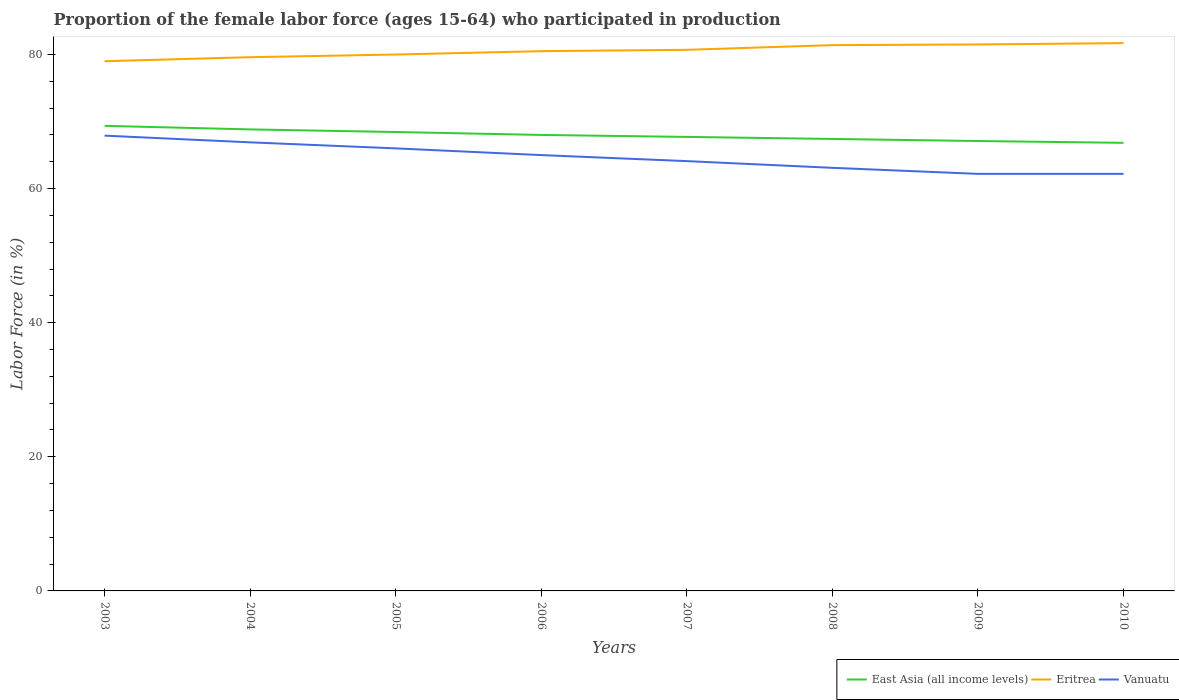Across all years, what is the maximum proportion of the female labor force who participated in production in East Asia (all income levels)?
Provide a short and direct response. 66.83. What is the total proportion of the female labor force who participated in production in East Asia (all income levels) in the graph?
Provide a succinct answer. 2.53. What is the difference between the highest and the second highest proportion of the female labor force who participated in production in Vanuatu?
Provide a succinct answer. 5.7. What is the difference between the highest and the lowest proportion of the female labor force who participated in production in Vanuatu?
Offer a very short reply. 4. How many lines are there?
Your answer should be compact. 3. What is the difference between two consecutive major ticks on the Y-axis?
Offer a very short reply. 20. Are the values on the major ticks of Y-axis written in scientific E-notation?
Keep it short and to the point. No. Does the graph contain any zero values?
Provide a short and direct response. No. Where does the legend appear in the graph?
Make the answer very short. Bottom right. How many legend labels are there?
Ensure brevity in your answer.  3. What is the title of the graph?
Ensure brevity in your answer.  Proportion of the female labor force (ages 15-64) who participated in production. What is the label or title of the X-axis?
Give a very brief answer. Years. What is the label or title of the Y-axis?
Provide a short and direct response. Labor Force (in %). What is the Labor Force (in %) of East Asia (all income levels) in 2003?
Provide a succinct answer. 69.36. What is the Labor Force (in %) in Eritrea in 2003?
Ensure brevity in your answer.  79. What is the Labor Force (in %) in Vanuatu in 2003?
Make the answer very short. 67.9. What is the Labor Force (in %) in East Asia (all income levels) in 2004?
Offer a terse response. 68.83. What is the Labor Force (in %) of Eritrea in 2004?
Give a very brief answer. 79.6. What is the Labor Force (in %) in Vanuatu in 2004?
Your response must be concise. 66.9. What is the Labor Force (in %) of East Asia (all income levels) in 2005?
Provide a succinct answer. 68.44. What is the Labor Force (in %) of Eritrea in 2005?
Your response must be concise. 80. What is the Labor Force (in %) in East Asia (all income levels) in 2006?
Offer a very short reply. 68.01. What is the Labor Force (in %) in Eritrea in 2006?
Your answer should be very brief. 80.5. What is the Labor Force (in %) in East Asia (all income levels) in 2007?
Ensure brevity in your answer.  67.71. What is the Labor Force (in %) in Eritrea in 2007?
Your answer should be very brief. 80.7. What is the Labor Force (in %) in Vanuatu in 2007?
Ensure brevity in your answer.  64.1. What is the Labor Force (in %) of East Asia (all income levels) in 2008?
Your answer should be compact. 67.41. What is the Labor Force (in %) of Eritrea in 2008?
Offer a terse response. 81.4. What is the Labor Force (in %) in Vanuatu in 2008?
Offer a terse response. 63.1. What is the Labor Force (in %) in East Asia (all income levels) in 2009?
Keep it short and to the point. 67.1. What is the Labor Force (in %) in Eritrea in 2009?
Make the answer very short. 81.5. What is the Labor Force (in %) in Vanuatu in 2009?
Your answer should be compact. 62.2. What is the Labor Force (in %) in East Asia (all income levels) in 2010?
Keep it short and to the point. 66.83. What is the Labor Force (in %) of Eritrea in 2010?
Give a very brief answer. 81.7. What is the Labor Force (in %) of Vanuatu in 2010?
Your answer should be very brief. 62.2. Across all years, what is the maximum Labor Force (in %) of East Asia (all income levels)?
Provide a short and direct response. 69.36. Across all years, what is the maximum Labor Force (in %) of Eritrea?
Your answer should be very brief. 81.7. Across all years, what is the maximum Labor Force (in %) of Vanuatu?
Your response must be concise. 67.9. Across all years, what is the minimum Labor Force (in %) in East Asia (all income levels)?
Keep it short and to the point. 66.83. Across all years, what is the minimum Labor Force (in %) of Eritrea?
Provide a short and direct response. 79. Across all years, what is the minimum Labor Force (in %) in Vanuatu?
Provide a short and direct response. 62.2. What is the total Labor Force (in %) of East Asia (all income levels) in the graph?
Make the answer very short. 543.69. What is the total Labor Force (in %) of Eritrea in the graph?
Give a very brief answer. 644.4. What is the total Labor Force (in %) of Vanuatu in the graph?
Keep it short and to the point. 517.4. What is the difference between the Labor Force (in %) of East Asia (all income levels) in 2003 and that in 2004?
Your answer should be compact. 0.53. What is the difference between the Labor Force (in %) of East Asia (all income levels) in 2003 and that in 2005?
Ensure brevity in your answer.  0.92. What is the difference between the Labor Force (in %) of Vanuatu in 2003 and that in 2005?
Your response must be concise. 1.9. What is the difference between the Labor Force (in %) in East Asia (all income levels) in 2003 and that in 2006?
Provide a short and direct response. 1.36. What is the difference between the Labor Force (in %) of Vanuatu in 2003 and that in 2006?
Provide a short and direct response. 2.9. What is the difference between the Labor Force (in %) of East Asia (all income levels) in 2003 and that in 2007?
Offer a terse response. 1.65. What is the difference between the Labor Force (in %) of Vanuatu in 2003 and that in 2007?
Your answer should be very brief. 3.8. What is the difference between the Labor Force (in %) of East Asia (all income levels) in 2003 and that in 2008?
Your response must be concise. 1.95. What is the difference between the Labor Force (in %) of Eritrea in 2003 and that in 2008?
Provide a short and direct response. -2.4. What is the difference between the Labor Force (in %) in Vanuatu in 2003 and that in 2008?
Your response must be concise. 4.8. What is the difference between the Labor Force (in %) in East Asia (all income levels) in 2003 and that in 2009?
Your response must be concise. 2.26. What is the difference between the Labor Force (in %) of Eritrea in 2003 and that in 2009?
Keep it short and to the point. -2.5. What is the difference between the Labor Force (in %) of Vanuatu in 2003 and that in 2009?
Your answer should be very brief. 5.7. What is the difference between the Labor Force (in %) in East Asia (all income levels) in 2003 and that in 2010?
Keep it short and to the point. 2.53. What is the difference between the Labor Force (in %) in Vanuatu in 2003 and that in 2010?
Ensure brevity in your answer.  5.7. What is the difference between the Labor Force (in %) of East Asia (all income levels) in 2004 and that in 2005?
Give a very brief answer. 0.39. What is the difference between the Labor Force (in %) of East Asia (all income levels) in 2004 and that in 2006?
Offer a terse response. 0.82. What is the difference between the Labor Force (in %) of East Asia (all income levels) in 2004 and that in 2007?
Your answer should be very brief. 1.12. What is the difference between the Labor Force (in %) of Vanuatu in 2004 and that in 2007?
Provide a succinct answer. 2.8. What is the difference between the Labor Force (in %) in East Asia (all income levels) in 2004 and that in 2008?
Keep it short and to the point. 1.42. What is the difference between the Labor Force (in %) of East Asia (all income levels) in 2004 and that in 2009?
Give a very brief answer. 1.73. What is the difference between the Labor Force (in %) in Eritrea in 2004 and that in 2009?
Ensure brevity in your answer.  -1.9. What is the difference between the Labor Force (in %) of East Asia (all income levels) in 2004 and that in 2010?
Provide a short and direct response. 2. What is the difference between the Labor Force (in %) of Eritrea in 2004 and that in 2010?
Offer a very short reply. -2.1. What is the difference between the Labor Force (in %) in Vanuatu in 2004 and that in 2010?
Offer a terse response. 4.7. What is the difference between the Labor Force (in %) in East Asia (all income levels) in 2005 and that in 2006?
Provide a short and direct response. 0.43. What is the difference between the Labor Force (in %) of Vanuatu in 2005 and that in 2006?
Give a very brief answer. 1. What is the difference between the Labor Force (in %) in East Asia (all income levels) in 2005 and that in 2007?
Provide a succinct answer. 0.73. What is the difference between the Labor Force (in %) in Vanuatu in 2005 and that in 2007?
Your response must be concise. 1.9. What is the difference between the Labor Force (in %) in East Asia (all income levels) in 2005 and that in 2008?
Keep it short and to the point. 1.03. What is the difference between the Labor Force (in %) of East Asia (all income levels) in 2005 and that in 2009?
Offer a terse response. 1.34. What is the difference between the Labor Force (in %) of Eritrea in 2005 and that in 2009?
Give a very brief answer. -1.5. What is the difference between the Labor Force (in %) in East Asia (all income levels) in 2005 and that in 2010?
Your response must be concise. 1.61. What is the difference between the Labor Force (in %) of East Asia (all income levels) in 2006 and that in 2007?
Your answer should be compact. 0.29. What is the difference between the Labor Force (in %) in East Asia (all income levels) in 2006 and that in 2008?
Your answer should be very brief. 0.6. What is the difference between the Labor Force (in %) of East Asia (all income levels) in 2006 and that in 2009?
Make the answer very short. 0.91. What is the difference between the Labor Force (in %) in East Asia (all income levels) in 2006 and that in 2010?
Offer a terse response. 1.18. What is the difference between the Labor Force (in %) of Eritrea in 2006 and that in 2010?
Offer a very short reply. -1.2. What is the difference between the Labor Force (in %) of East Asia (all income levels) in 2007 and that in 2008?
Make the answer very short. 0.3. What is the difference between the Labor Force (in %) in Eritrea in 2007 and that in 2008?
Provide a short and direct response. -0.7. What is the difference between the Labor Force (in %) of East Asia (all income levels) in 2007 and that in 2009?
Provide a succinct answer. 0.61. What is the difference between the Labor Force (in %) in Eritrea in 2007 and that in 2009?
Provide a succinct answer. -0.8. What is the difference between the Labor Force (in %) of East Asia (all income levels) in 2007 and that in 2010?
Offer a terse response. 0.88. What is the difference between the Labor Force (in %) of East Asia (all income levels) in 2008 and that in 2009?
Offer a terse response. 0.31. What is the difference between the Labor Force (in %) of Vanuatu in 2008 and that in 2009?
Offer a very short reply. 0.9. What is the difference between the Labor Force (in %) in East Asia (all income levels) in 2008 and that in 2010?
Provide a succinct answer. 0.58. What is the difference between the Labor Force (in %) in Eritrea in 2008 and that in 2010?
Ensure brevity in your answer.  -0.3. What is the difference between the Labor Force (in %) of East Asia (all income levels) in 2009 and that in 2010?
Make the answer very short. 0.27. What is the difference between the Labor Force (in %) of Eritrea in 2009 and that in 2010?
Give a very brief answer. -0.2. What is the difference between the Labor Force (in %) of Vanuatu in 2009 and that in 2010?
Offer a very short reply. 0. What is the difference between the Labor Force (in %) of East Asia (all income levels) in 2003 and the Labor Force (in %) of Eritrea in 2004?
Your response must be concise. -10.24. What is the difference between the Labor Force (in %) in East Asia (all income levels) in 2003 and the Labor Force (in %) in Vanuatu in 2004?
Make the answer very short. 2.46. What is the difference between the Labor Force (in %) in East Asia (all income levels) in 2003 and the Labor Force (in %) in Eritrea in 2005?
Ensure brevity in your answer.  -10.64. What is the difference between the Labor Force (in %) in East Asia (all income levels) in 2003 and the Labor Force (in %) in Vanuatu in 2005?
Your answer should be very brief. 3.36. What is the difference between the Labor Force (in %) of Eritrea in 2003 and the Labor Force (in %) of Vanuatu in 2005?
Make the answer very short. 13. What is the difference between the Labor Force (in %) of East Asia (all income levels) in 2003 and the Labor Force (in %) of Eritrea in 2006?
Make the answer very short. -11.14. What is the difference between the Labor Force (in %) in East Asia (all income levels) in 2003 and the Labor Force (in %) in Vanuatu in 2006?
Offer a terse response. 4.36. What is the difference between the Labor Force (in %) in Eritrea in 2003 and the Labor Force (in %) in Vanuatu in 2006?
Keep it short and to the point. 14. What is the difference between the Labor Force (in %) in East Asia (all income levels) in 2003 and the Labor Force (in %) in Eritrea in 2007?
Give a very brief answer. -11.34. What is the difference between the Labor Force (in %) in East Asia (all income levels) in 2003 and the Labor Force (in %) in Vanuatu in 2007?
Your answer should be very brief. 5.26. What is the difference between the Labor Force (in %) in Eritrea in 2003 and the Labor Force (in %) in Vanuatu in 2007?
Offer a terse response. 14.9. What is the difference between the Labor Force (in %) in East Asia (all income levels) in 2003 and the Labor Force (in %) in Eritrea in 2008?
Offer a terse response. -12.04. What is the difference between the Labor Force (in %) of East Asia (all income levels) in 2003 and the Labor Force (in %) of Vanuatu in 2008?
Your answer should be compact. 6.26. What is the difference between the Labor Force (in %) of East Asia (all income levels) in 2003 and the Labor Force (in %) of Eritrea in 2009?
Offer a very short reply. -12.14. What is the difference between the Labor Force (in %) in East Asia (all income levels) in 2003 and the Labor Force (in %) in Vanuatu in 2009?
Keep it short and to the point. 7.16. What is the difference between the Labor Force (in %) of Eritrea in 2003 and the Labor Force (in %) of Vanuatu in 2009?
Your answer should be compact. 16.8. What is the difference between the Labor Force (in %) of East Asia (all income levels) in 2003 and the Labor Force (in %) of Eritrea in 2010?
Provide a succinct answer. -12.34. What is the difference between the Labor Force (in %) in East Asia (all income levels) in 2003 and the Labor Force (in %) in Vanuatu in 2010?
Make the answer very short. 7.16. What is the difference between the Labor Force (in %) of Eritrea in 2003 and the Labor Force (in %) of Vanuatu in 2010?
Provide a succinct answer. 16.8. What is the difference between the Labor Force (in %) in East Asia (all income levels) in 2004 and the Labor Force (in %) in Eritrea in 2005?
Your answer should be compact. -11.17. What is the difference between the Labor Force (in %) in East Asia (all income levels) in 2004 and the Labor Force (in %) in Vanuatu in 2005?
Provide a short and direct response. 2.83. What is the difference between the Labor Force (in %) in East Asia (all income levels) in 2004 and the Labor Force (in %) in Eritrea in 2006?
Provide a succinct answer. -11.67. What is the difference between the Labor Force (in %) of East Asia (all income levels) in 2004 and the Labor Force (in %) of Vanuatu in 2006?
Provide a succinct answer. 3.83. What is the difference between the Labor Force (in %) of Eritrea in 2004 and the Labor Force (in %) of Vanuatu in 2006?
Offer a terse response. 14.6. What is the difference between the Labor Force (in %) in East Asia (all income levels) in 2004 and the Labor Force (in %) in Eritrea in 2007?
Your answer should be very brief. -11.87. What is the difference between the Labor Force (in %) in East Asia (all income levels) in 2004 and the Labor Force (in %) in Vanuatu in 2007?
Offer a very short reply. 4.73. What is the difference between the Labor Force (in %) in Eritrea in 2004 and the Labor Force (in %) in Vanuatu in 2007?
Provide a short and direct response. 15.5. What is the difference between the Labor Force (in %) of East Asia (all income levels) in 2004 and the Labor Force (in %) of Eritrea in 2008?
Offer a very short reply. -12.57. What is the difference between the Labor Force (in %) of East Asia (all income levels) in 2004 and the Labor Force (in %) of Vanuatu in 2008?
Ensure brevity in your answer.  5.73. What is the difference between the Labor Force (in %) of East Asia (all income levels) in 2004 and the Labor Force (in %) of Eritrea in 2009?
Your answer should be very brief. -12.67. What is the difference between the Labor Force (in %) in East Asia (all income levels) in 2004 and the Labor Force (in %) in Vanuatu in 2009?
Your answer should be very brief. 6.63. What is the difference between the Labor Force (in %) of East Asia (all income levels) in 2004 and the Labor Force (in %) of Eritrea in 2010?
Offer a very short reply. -12.87. What is the difference between the Labor Force (in %) in East Asia (all income levels) in 2004 and the Labor Force (in %) in Vanuatu in 2010?
Offer a very short reply. 6.63. What is the difference between the Labor Force (in %) in Eritrea in 2004 and the Labor Force (in %) in Vanuatu in 2010?
Provide a succinct answer. 17.4. What is the difference between the Labor Force (in %) in East Asia (all income levels) in 2005 and the Labor Force (in %) in Eritrea in 2006?
Offer a very short reply. -12.06. What is the difference between the Labor Force (in %) in East Asia (all income levels) in 2005 and the Labor Force (in %) in Vanuatu in 2006?
Provide a succinct answer. 3.44. What is the difference between the Labor Force (in %) in Eritrea in 2005 and the Labor Force (in %) in Vanuatu in 2006?
Provide a short and direct response. 15. What is the difference between the Labor Force (in %) in East Asia (all income levels) in 2005 and the Labor Force (in %) in Eritrea in 2007?
Keep it short and to the point. -12.26. What is the difference between the Labor Force (in %) in East Asia (all income levels) in 2005 and the Labor Force (in %) in Vanuatu in 2007?
Offer a terse response. 4.34. What is the difference between the Labor Force (in %) in Eritrea in 2005 and the Labor Force (in %) in Vanuatu in 2007?
Your answer should be very brief. 15.9. What is the difference between the Labor Force (in %) in East Asia (all income levels) in 2005 and the Labor Force (in %) in Eritrea in 2008?
Provide a succinct answer. -12.96. What is the difference between the Labor Force (in %) in East Asia (all income levels) in 2005 and the Labor Force (in %) in Vanuatu in 2008?
Your answer should be compact. 5.34. What is the difference between the Labor Force (in %) in East Asia (all income levels) in 2005 and the Labor Force (in %) in Eritrea in 2009?
Make the answer very short. -13.06. What is the difference between the Labor Force (in %) in East Asia (all income levels) in 2005 and the Labor Force (in %) in Vanuatu in 2009?
Ensure brevity in your answer.  6.24. What is the difference between the Labor Force (in %) in Eritrea in 2005 and the Labor Force (in %) in Vanuatu in 2009?
Your answer should be compact. 17.8. What is the difference between the Labor Force (in %) of East Asia (all income levels) in 2005 and the Labor Force (in %) of Eritrea in 2010?
Ensure brevity in your answer.  -13.26. What is the difference between the Labor Force (in %) in East Asia (all income levels) in 2005 and the Labor Force (in %) in Vanuatu in 2010?
Keep it short and to the point. 6.24. What is the difference between the Labor Force (in %) in Eritrea in 2005 and the Labor Force (in %) in Vanuatu in 2010?
Keep it short and to the point. 17.8. What is the difference between the Labor Force (in %) of East Asia (all income levels) in 2006 and the Labor Force (in %) of Eritrea in 2007?
Provide a short and direct response. -12.69. What is the difference between the Labor Force (in %) in East Asia (all income levels) in 2006 and the Labor Force (in %) in Vanuatu in 2007?
Your answer should be very brief. 3.91. What is the difference between the Labor Force (in %) in Eritrea in 2006 and the Labor Force (in %) in Vanuatu in 2007?
Offer a very short reply. 16.4. What is the difference between the Labor Force (in %) of East Asia (all income levels) in 2006 and the Labor Force (in %) of Eritrea in 2008?
Your response must be concise. -13.39. What is the difference between the Labor Force (in %) in East Asia (all income levels) in 2006 and the Labor Force (in %) in Vanuatu in 2008?
Keep it short and to the point. 4.91. What is the difference between the Labor Force (in %) of East Asia (all income levels) in 2006 and the Labor Force (in %) of Eritrea in 2009?
Provide a succinct answer. -13.49. What is the difference between the Labor Force (in %) in East Asia (all income levels) in 2006 and the Labor Force (in %) in Vanuatu in 2009?
Provide a succinct answer. 5.81. What is the difference between the Labor Force (in %) of East Asia (all income levels) in 2006 and the Labor Force (in %) of Eritrea in 2010?
Ensure brevity in your answer.  -13.69. What is the difference between the Labor Force (in %) of East Asia (all income levels) in 2006 and the Labor Force (in %) of Vanuatu in 2010?
Your answer should be compact. 5.81. What is the difference between the Labor Force (in %) in East Asia (all income levels) in 2007 and the Labor Force (in %) in Eritrea in 2008?
Ensure brevity in your answer.  -13.69. What is the difference between the Labor Force (in %) of East Asia (all income levels) in 2007 and the Labor Force (in %) of Vanuatu in 2008?
Make the answer very short. 4.61. What is the difference between the Labor Force (in %) of East Asia (all income levels) in 2007 and the Labor Force (in %) of Eritrea in 2009?
Keep it short and to the point. -13.79. What is the difference between the Labor Force (in %) of East Asia (all income levels) in 2007 and the Labor Force (in %) of Vanuatu in 2009?
Your response must be concise. 5.51. What is the difference between the Labor Force (in %) of East Asia (all income levels) in 2007 and the Labor Force (in %) of Eritrea in 2010?
Ensure brevity in your answer.  -13.99. What is the difference between the Labor Force (in %) in East Asia (all income levels) in 2007 and the Labor Force (in %) in Vanuatu in 2010?
Your response must be concise. 5.51. What is the difference between the Labor Force (in %) in Eritrea in 2007 and the Labor Force (in %) in Vanuatu in 2010?
Offer a terse response. 18.5. What is the difference between the Labor Force (in %) in East Asia (all income levels) in 2008 and the Labor Force (in %) in Eritrea in 2009?
Make the answer very short. -14.09. What is the difference between the Labor Force (in %) in East Asia (all income levels) in 2008 and the Labor Force (in %) in Vanuatu in 2009?
Your answer should be compact. 5.21. What is the difference between the Labor Force (in %) in Eritrea in 2008 and the Labor Force (in %) in Vanuatu in 2009?
Ensure brevity in your answer.  19.2. What is the difference between the Labor Force (in %) of East Asia (all income levels) in 2008 and the Labor Force (in %) of Eritrea in 2010?
Your response must be concise. -14.29. What is the difference between the Labor Force (in %) of East Asia (all income levels) in 2008 and the Labor Force (in %) of Vanuatu in 2010?
Keep it short and to the point. 5.21. What is the difference between the Labor Force (in %) of Eritrea in 2008 and the Labor Force (in %) of Vanuatu in 2010?
Provide a succinct answer. 19.2. What is the difference between the Labor Force (in %) in East Asia (all income levels) in 2009 and the Labor Force (in %) in Eritrea in 2010?
Your answer should be compact. -14.6. What is the difference between the Labor Force (in %) of East Asia (all income levels) in 2009 and the Labor Force (in %) of Vanuatu in 2010?
Provide a succinct answer. 4.9. What is the difference between the Labor Force (in %) of Eritrea in 2009 and the Labor Force (in %) of Vanuatu in 2010?
Provide a short and direct response. 19.3. What is the average Labor Force (in %) of East Asia (all income levels) per year?
Make the answer very short. 67.96. What is the average Labor Force (in %) of Eritrea per year?
Your answer should be compact. 80.55. What is the average Labor Force (in %) of Vanuatu per year?
Offer a very short reply. 64.67. In the year 2003, what is the difference between the Labor Force (in %) in East Asia (all income levels) and Labor Force (in %) in Eritrea?
Offer a very short reply. -9.64. In the year 2003, what is the difference between the Labor Force (in %) of East Asia (all income levels) and Labor Force (in %) of Vanuatu?
Provide a succinct answer. 1.46. In the year 2003, what is the difference between the Labor Force (in %) of Eritrea and Labor Force (in %) of Vanuatu?
Your response must be concise. 11.1. In the year 2004, what is the difference between the Labor Force (in %) of East Asia (all income levels) and Labor Force (in %) of Eritrea?
Provide a succinct answer. -10.77. In the year 2004, what is the difference between the Labor Force (in %) in East Asia (all income levels) and Labor Force (in %) in Vanuatu?
Your answer should be very brief. 1.93. In the year 2004, what is the difference between the Labor Force (in %) in Eritrea and Labor Force (in %) in Vanuatu?
Your answer should be very brief. 12.7. In the year 2005, what is the difference between the Labor Force (in %) in East Asia (all income levels) and Labor Force (in %) in Eritrea?
Offer a terse response. -11.56. In the year 2005, what is the difference between the Labor Force (in %) of East Asia (all income levels) and Labor Force (in %) of Vanuatu?
Give a very brief answer. 2.44. In the year 2006, what is the difference between the Labor Force (in %) of East Asia (all income levels) and Labor Force (in %) of Eritrea?
Offer a very short reply. -12.49. In the year 2006, what is the difference between the Labor Force (in %) of East Asia (all income levels) and Labor Force (in %) of Vanuatu?
Make the answer very short. 3.01. In the year 2007, what is the difference between the Labor Force (in %) of East Asia (all income levels) and Labor Force (in %) of Eritrea?
Your answer should be compact. -12.99. In the year 2007, what is the difference between the Labor Force (in %) of East Asia (all income levels) and Labor Force (in %) of Vanuatu?
Your answer should be compact. 3.61. In the year 2007, what is the difference between the Labor Force (in %) of Eritrea and Labor Force (in %) of Vanuatu?
Your answer should be compact. 16.6. In the year 2008, what is the difference between the Labor Force (in %) of East Asia (all income levels) and Labor Force (in %) of Eritrea?
Your answer should be compact. -13.99. In the year 2008, what is the difference between the Labor Force (in %) in East Asia (all income levels) and Labor Force (in %) in Vanuatu?
Your answer should be very brief. 4.31. In the year 2009, what is the difference between the Labor Force (in %) of East Asia (all income levels) and Labor Force (in %) of Eritrea?
Make the answer very short. -14.4. In the year 2009, what is the difference between the Labor Force (in %) of East Asia (all income levels) and Labor Force (in %) of Vanuatu?
Ensure brevity in your answer.  4.9. In the year 2009, what is the difference between the Labor Force (in %) in Eritrea and Labor Force (in %) in Vanuatu?
Provide a succinct answer. 19.3. In the year 2010, what is the difference between the Labor Force (in %) of East Asia (all income levels) and Labor Force (in %) of Eritrea?
Your answer should be very brief. -14.87. In the year 2010, what is the difference between the Labor Force (in %) of East Asia (all income levels) and Labor Force (in %) of Vanuatu?
Your answer should be very brief. 4.63. What is the ratio of the Labor Force (in %) in East Asia (all income levels) in 2003 to that in 2004?
Provide a succinct answer. 1.01. What is the ratio of the Labor Force (in %) in Eritrea in 2003 to that in 2004?
Your answer should be compact. 0.99. What is the ratio of the Labor Force (in %) in Vanuatu in 2003 to that in 2004?
Provide a succinct answer. 1.01. What is the ratio of the Labor Force (in %) of East Asia (all income levels) in 2003 to that in 2005?
Ensure brevity in your answer.  1.01. What is the ratio of the Labor Force (in %) in Eritrea in 2003 to that in 2005?
Your answer should be very brief. 0.99. What is the ratio of the Labor Force (in %) of Vanuatu in 2003 to that in 2005?
Keep it short and to the point. 1.03. What is the ratio of the Labor Force (in %) of East Asia (all income levels) in 2003 to that in 2006?
Make the answer very short. 1.02. What is the ratio of the Labor Force (in %) of Eritrea in 2003 to that in 2006?
Your response must be concise. 0.98. What is the ratio of the Labor Force (in %) in Vanuatu in 2003 to that in 2006?
Your response must be concise. 1.04. What is the ratio of the Labor Force (in %) in East Asia (all income levels) in 2003 to that in 2007?
Provide a short and direct response. 1.02. What is the ratio of the Labor Force (in %) in Eritrea in 2003 to that in 2007?
Ensure brevity in your answer.  0.98. What is the ratio of the Labor Force (in %) of Vanuatu in 2003 to that in 2007?
Make the answer very short. 1.06. What is the ratio of the Labor Force (in %) in East Asia (all income levels) in 2003 to that in 2008?
Keep it short and to the point. 1.03. What is the ratio of the Labor Force (in %) of Eritrea in 2003 to that in 2008?
Give a very brief answer. 0.97. What is the ratio of the Labor Force (in %) of Vanuatu in 2003 to that in 2008?
Your response must be concise. 1.08. What is the ratio of the Labor Force (in %) in East Asia (all income levels) in 2003 to that in 2009?
Offer a very short reply. 1.03. What is the ratio of the Labor Force (in %) in Eritrea in 2003 to that in 2009?
Ensure brevity in your answer.  0.97. What is the ratio of the Labor Force (in %) in Vanuatu in 2003 to that in 2009?
Your answer should be very brief. 1.09. What is the ratio of the Labor Force (in %) in East Asia (all income levels) in 2003 to that in 2010?
Your answer should be compact. 1.04. What is the ratio of the Labor Force (in %) in Vanuatu in 2003 to that in 2010?
Your response must be concise. 1.09. What is the ratio of the Labor Force (in %) in Eritrea in 2004 to that in 2005?
Ensure brevity in your answer.  0.99. What is the ratio of the Labor Force (in %) of Vanuatu in 2004 to that in 2005?
Offer a terse response. 1.01. What is the ratio of the Labor Force (in %) of East Asia (all income levels) in 2004 to that in 2006?
Your response must be concise. 1.01. What is the ratio of the Labor Force (in %) in Eritrea in 2004 to that in 2006?
Provide a short and direct response. 0.99. What is the ratio of the Labor Force (in %) in Vanuatu in 2004 to that in 2006?
Give a very brief answer. 1.03. What is the ratio of the Labor Force (in %) in East Asia (all income levels) in 2004 to that in 2007?
Offer a very short reply. 1.02. What is the ratio of the Labor Force (in %) of Eritrea in 2004 to that in 2007?
Give a very brief answer. 0.99. What is the ratio of the Labor Force (in %) in Vanuatu in 2004 to that in 2007?
Offer a terse response. 1.04. What is the ratio of the Labor Force (in %) of East Asia (all income levels) in 2004 to that in 2008?
Give a very brief answer. 1.02. What is the ratio of the Labor Force (in %) in Eritrea in 2004 to that in 2008?
Your answer should be very brief. 0.98. What is the ratio of the Labor Force (in %) in Vanuatu in 2004 to that in 2008?
Provide a short and direct response. 1.06. What is the ratio of the Labor Force (in %) in East Asia (all income levels) in 2004 to that in 2009?
Offer a very short reply. 1.03. What is the ratio of the Labor Force (in %) of Eritrea in 2004 to that in 2009?
Your response must be concise. 0.98. What is the ratio of the Labor Force (in %) of Vanuatu in 2004 to that in 2009?
Your response must be concise. 1.08. What is the ratio of the Labor Force (in %) in East Asia (all income levels) in 2004 to that in 2010?
Keep it short and to the point. 1.03. What is the ratio of the Labor Force (in %) in Eritrea in 2004 to that in 2010?
Give a very brief answer. 0.97. What is the ratio of the Labor Force (in %) of Vanuatu in 2004 to that in 2010?
Your answer should be very brief. 1.08. What is the ratio of the Labor Force (in %) of East Asia (all income levels) in 2005 to that in 2006?
Offer a very short reply. 1.01. What is the ratio of the Labor Force (in %) of Eritrea in 2005 to that in 2006?
Provide a short and direct response. 0.99. What is the ratio of the Labor Force (in %) of Vanuatu in 2005 to that in 2006?
Give a very brief answer. 1.02. What is the ratio of the Labor Force (in %) of East Asia (all income levels) in 2005 to that in 2007?
Provide a short and direct response. 1.01. What is the ratio of the Labor Force (in %) of Eritrea in 2005 to that in 2007?
Make the answer very short. 0.99. What is the ratio of the Labor Force (in %) of Vanuatu in 2005 to that in 2007?
Provide a short and direct response. 1.03. What is the ratio of the Labor Force (in %) in East Asia (all income levels) in 2005 to that in 2008?
Provide a short and direct response. 1.02. What is the ratio of the Labor Force (in %) of Eritrea in 2005 to that in 2008?
Provide a succinct answer. 0.98. What is the ratio of the Labor Force (in %) in Vanuatu in 2005 to that in 2008?
Keep it short and to the point. 1.05. What is the ratio of the Labor Force (in %) in East Asia (all income levels) in 2005 to that in 2009?
Offer a terse response. 1.02. What is the ratio of the Labor Force (in %) in Eritrea in 2005 to that in 2009?
Make the answer very short. 0.98. What is the ratio of the Labor Force (in %) in Vanuatu in 2005 to that in 2009?
Offer a terse response. 1.06. What is the ratio of the Labor Force (in %) in East Asia (all income levels) in 2005 to that in 2010?
Provide a succinct answer. 1.02. What is the ratio of the Labor Force (in %) of Eritrea in 2005 to that in 2010?
Provide a short and direct response. 0.98. What is the ratio of the Labor Force (in %) in Vanuatu in 2005 to that in 2010?
Offer a terse response. 1.06. What is the ratio of the Labor Force (in %) in East Asia (all income levels) in 2006 to that in 2008?
Offer a terse response. 1.01. What is the ratio of the Labor Force (in %) of Eritrea in 2006 to that in 2008?
Provide a succinct answer. 0.99. What is the ratio of the Labor Force (in %) in Vanuatu in 2006 to that in 2008?
Your answer should be very brief. 1.03. What is the ratio of the Labor Force (in %) of East Asia (all income levels) in 2006 to that in 2009?
Your answer should be compact. 1.01. What is the ratio of the Labor Force (in %) in Vanuatu in 2006 to that in 2009?
Provide a short and direct response. 1.04. What is the ratio of the Labor Force (in %) in East Asia (all income levels) in 2006 to that in 2010?
Ensure brevity in your answer.  1.02. What is the ratio of the Labor Force (in %) in Vanuatu in 2006 to that in 2010?
Make the answer very short. 1.04. What is the ratio of the Labor Force (in %) in East Asia (all income levels) in 2007 to that in 2008?
Your answer should be compact. 1. What is the ratio of the Labor Force (in %) in Vanuatu in 2007 to that in 2008?
Keep it short and to the point. 1.02. What is the ratio of the Labor Force (in %) in East Asia (all income levels) in 2007 to that in 2009?
Give a very brief answer. 1.01. What is the ratio of the Labor Force (in %) in Eritrea in 2007 to that in 2009?
Your response must be concise. 0.99. What is the ratio of the Labor Force (in %) of Vanuatu in 2007 to that in 2009?
Your response must be concise. 1.03. What is the ratio of the Labor Force (in %) in East Asia (all income levels) in 2007 to that in 2010?
Make the answer very short. 1.01. What is the ratio of the Labor Force (in %) of Vanuatu in 2007 to that in 2010?
Offer a terse response. 1.03. What is the ratio of the Labor Force (in %) in East Asia (all income levels) in 2008 to that in 2009?
Provide a succinct answer. 1. What is the ratio of the Labor Force (in %) in Eritrea in 2008 to that in 2009?
Provide a succinct answer. 1. What is the ratio of the Labor Force (in %) of Vanuatu in 2008 to that in 2009?
Your response must be concise. 1.01. What is the ratio of the Labor Force (in %) in East Asia (all income levels) in 2008 to that in 2010?
Make the answer very short. 1.01. What is the ratio of the Labor Force (in %) in Vanuatu in 2008 to that in 2010?
Your answer should be compact. 1.01. What is the ratio of the Labor Force (in %) in East Asia (all income levels) in 2009 to that in 2010?
Offer a very short reply. 1. What is the ratio of the Labor Force (in %) in Vanuatu in 2009 to that in 2010?
Provide a succinct answer. 1. What is the difference between the highest and the second highest Labor Force (in %) of East Asia (all income levels)?
Keep it short and to the point. 0.53. What is the difference between the highest and the lowest Labor Force (in %) of East Asia (all income levels)?
Give a very brief answer. 2.53. What is the difference between the highest and the lowest Labor Force (in %) in Eritrea?
Give a very brief answer. 2.7. What is the difference between the highest and the lowest Labor Force (in %) of Vanuatu?
Make the answer very short. 5.7. 